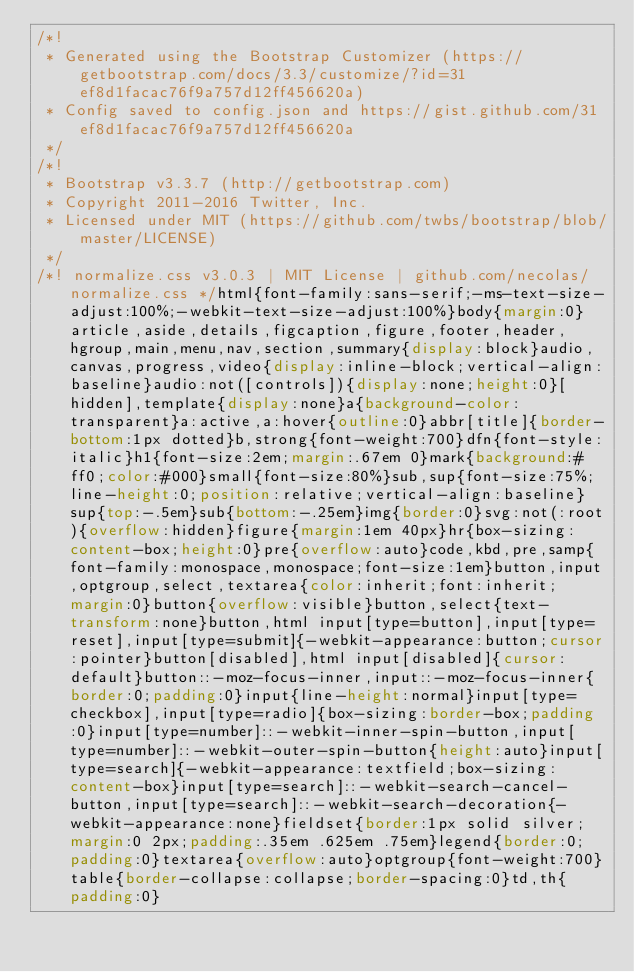Convert code to text. <code><loc_0><loc_0><loc_500><loc_500><_CSS_>/*!
 * Generated using the Bootstrap Customizer (https://getbootstrap.com/docs/3.3/customize/?id=31ef8d1facac76f9a757d12ff456620a)
 * Config saved to config.json and https://gist.github.com/31ef8d1facac76f9a757d12ff456620a
 */
/*!
 * Bootstrap v3.3.7 (http://getbootstrap.com)
 * Copyright 2011-2016 Twitter, Inc.
 * Licensed under MIT (https://github.com/twbs/bootstrap/blob/master/LICENSE)
 */
/*! normalize.css v3.0.3 | MIT License | github.com/necolas/normalize.css */html{font-family:sans-serif;-ms-text-size-adjust:100%;-webkit-text-size-adjust:100%}body{margin:0}article,aside,details,figcaption,figure,footer,header,hgroup,main,menu,nav,section,summary{display:block}audio,canvas,progress,video{display:inline-block;vertical-align:baseline}audio:not([controls]){display:none;height:0}[hidden],template{display:none}a{background-color:transparent}a:active,a:hover{outline:0}abbr[title]{border-bottom:1px dotted}b,strong{font-weight:700}dfn{font-style:italic}h1{font-size:2em;margin:.67em 0}mark{background:#ff0;color:#000}small{font-size:80%}sub,sup{font-size:75%;line-height:0;position:relative;vertical-align:baseline}sup{top:-.5em}sub{bottom:-.25em}img{border:0}svg:not(:root){overflow:hidden}figure{margin:1em 40px}hr{box-sizing:content-box;height:0}pre{overflow:auto}code,kbd,pre,samp{font-family:monospace,monospace;font-size:1em}button,input,optgroup,select,textarea{color:inherit;font:inherit;margin:0}button{overflow:visible}button,select{text-transform:none}button,html input[type=button],input[type=reset],input[type=submit]{-webkit-appearance:button;cursor:pointer}button[disabled],html input[disabled]{cursor:default}button::-moz-focus-inner,input::-moz-focus-inner{border:0;padding:0}input{line-height:normal}input[type=checkbox],input[type=radio]{box-sizing:border-box;padding:0}input[type=number]::-webkit-inner-spin-button,input[type=number]::-webkit-outer-spin-button{height:auto}input[type=search]{-webkit-appearance:textfield;box-sizing:content-box}input[type=search]::-webkit-search-cancel-button,input[type=search]::-webkit-search-decoration{-webkit-appearance:none}fieldset{border:1px solid silver;margin:0 2px;padding:.35em .625em .75em}legend{border:0;padding:0}textarea{overflow:auto}optgroup{font-weight:700}table{border-collapse:collapse;border-spacing:0}td,th{padding:0}</code> 